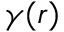Convert formula to latex. <formula><loc_0><loc_0><loc_500><loc_500>\gamma ( r )</formula> 